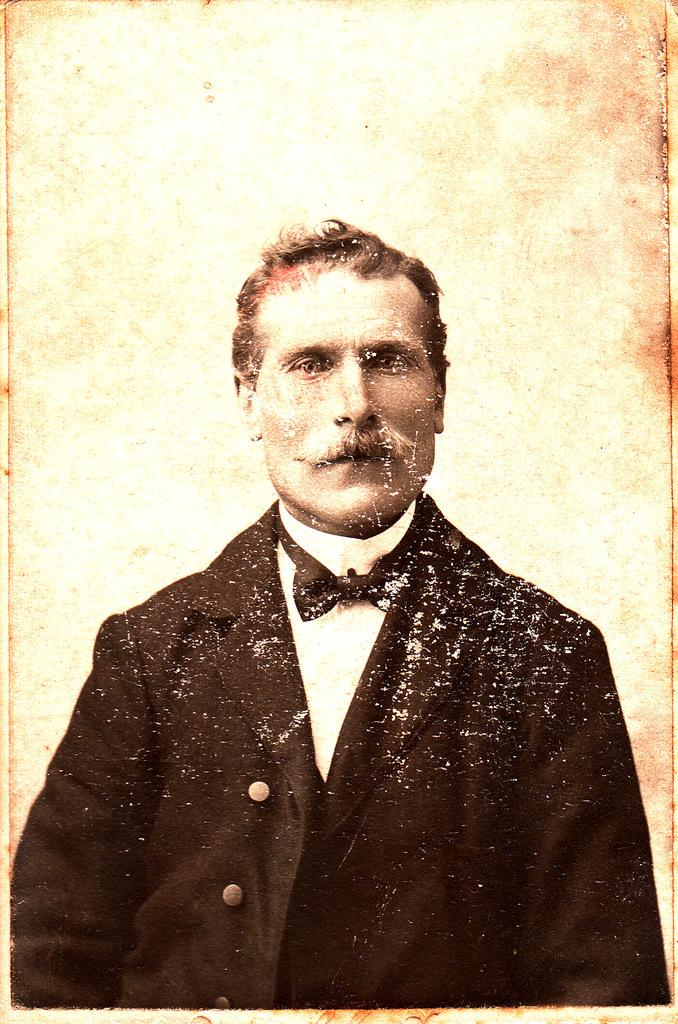Who or what is the main subject of the image? There is a person in the image. What type of clothing is the person wearing on their upper body? The person is wearing a blazer. What type of accessory is the person wearing around their neck? The person is wearing a bow tie. What time does the clock in the image show? There is no clock present in the image. What type of street is visible in the image? There is no street visible in the image. 